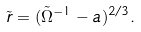Convert formula to latex. <formula><loc_0><loc_0><loc_500><loc_500>\tilde { r } = ( \tilde { \Omega } ^ { - 1 } - a ) ^ { 2 / 3 } .</formula> 